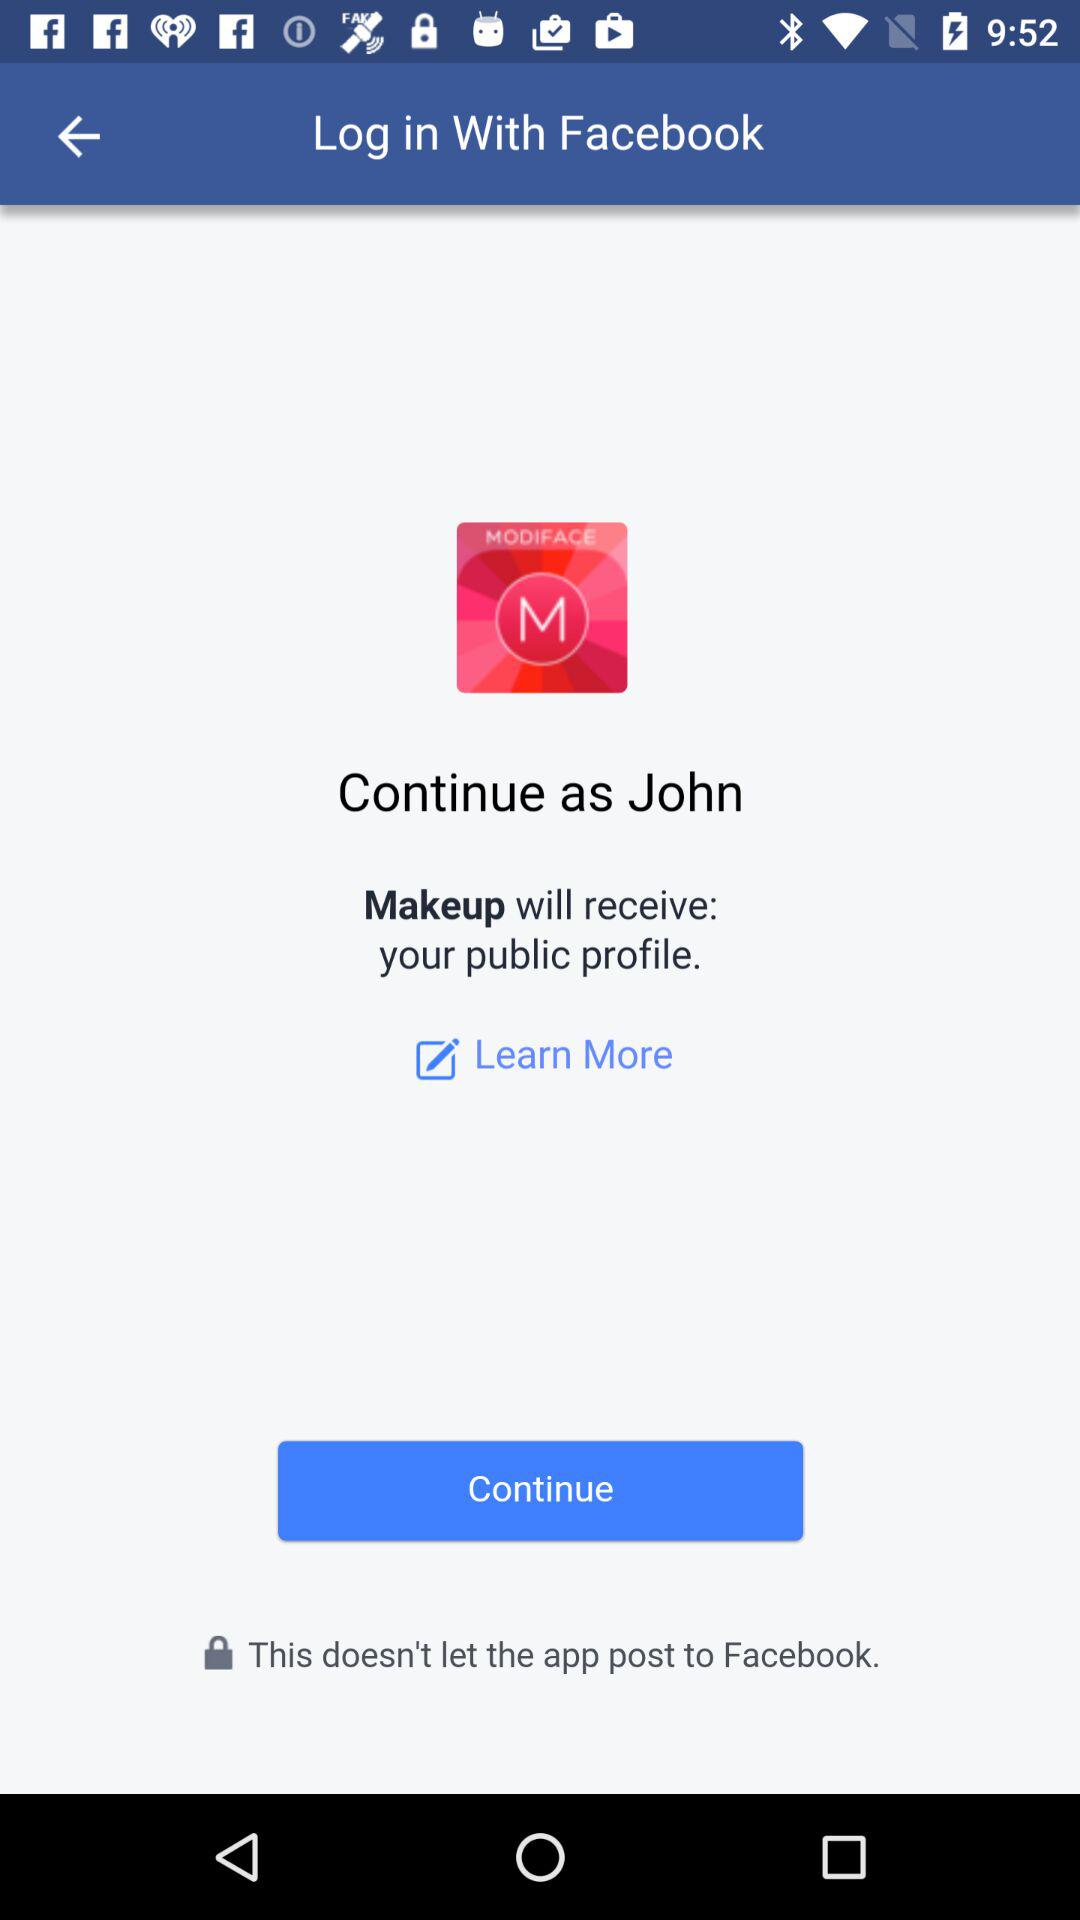What is the name of the user? The name of the user is John. 